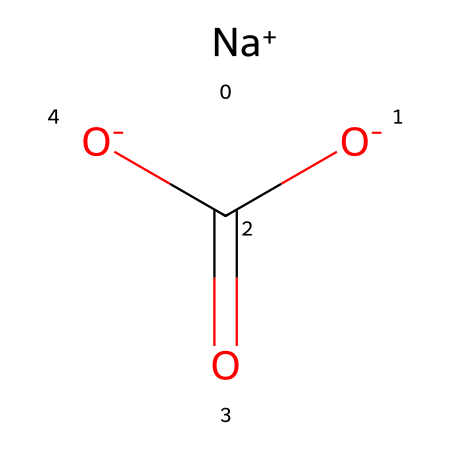What is the common name for this chemical? The SMILES representation corresponds to sodium bicarbonate, commonly known as baking soda. This is derived from the presence of sodium (Na) and bicarbonate (the CO3 group with a negative charge from O).
Answer: sodium bicarbonate How many oxygen atoms are present in this chemical? Examining the SMILES notation, [O-]C(=O)[O-] includes three oxygen atoms in total: one in the bicarbonate group and two in the dioxide part.
Answer: three What is the charge of sodium in this compound? The notation [Na+] indicates that sodium carries a positive one charge, as designated by the "+" sign.
Answer: positive one Which functional group is present in sodium bicarbonate? The presence of the CO3 part identifies it as a bicarbonate group, which is the functional characteristic that defines this compound as a base.
Answer: bicarbonate group Why is sodium bicarbonate considered a base? Sodium bicarbonate can accept protons (H+) from acids, thus increasing the pH of a solution. The presence of the bicarbonate ion (HCO3-) allows it to neutralize acids.
Answer: because it accepts protons How many carbon atoms are in sodium bicarbonate? The SMILES structure C(=O) indicates that there is one carbon atom in the bicyclic structure present within the molecule.
Answer: one What role does sodium bicarbonate play in cheese production? Sodium bicarbonate acts as a buffering agent, helping to control acidity levels during cheese fermentation, crucial for taste and consistency.
Answer: buffering agent 